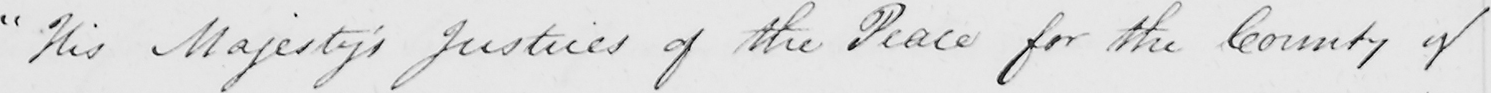What text is written in this handwritten line? " His Majesty ' s Justices of the Peace for the County of 